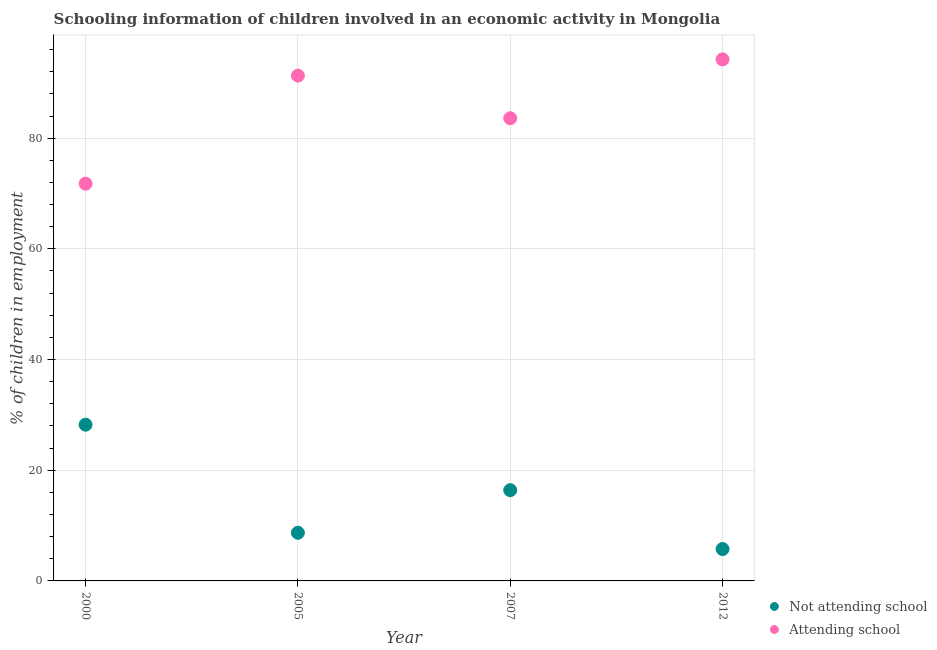How many different coloured dotlines are there?
Your answer should be very brief. 2. What is the percentage of employed children who are attending school in 2005?
Offer a terse response. 91.3. Across all years, what is the maximum percentage of employed children who are attending school?
Ensure brevity in your answer.  94.24. Across all years, what is the minimum percentage of employed children who are not attending school?
Provide a short and direct response. 5.76. What is the total percentage of employed children who are attending school in the graph?
Offer a very short reply. 340.91. What is the difference between the percentage of employed children who are attending school in 2005 and that in 2007?
Your response must be concise. 7.7. What is the difference between the percentage of employed children who are not attending school in 2007 and the percentage of employed children who are attending school in 2005?
Provide a short and direct response. -74.9. What is the average percentage of employed children who are attending school per year?
Provide a short and direct response. 85.23. In the year 2000, what is the difference between the percentage of employed children who are not attending school and percentage of employed children who are attending school?
Your response must be concise. -43.55. In how many years, is the percentage of employed children who are not attending school greater than 52 %?
Make the answer very short. 0. What is the ratio of the percentage of employed children who are not attending school in 2000 to that in 2007?
Offer a terse response. 1.72. Is the percentage of employed children who are attending school in 2000 less than that in 2007?
Keep it short and to the point. Yes. Is the difference between the percentage of employed children who are attending school in 2005 and 2007 greater than the difference between the percentage of employed children who are not attending school in 2005 and 2007?
Your answer should be compact. Yes. What is the difference between the highest and the second highest percentage of employed children who are not attending school?
Provide a short and direct response. 11.83. What is the difference between the highest and the lowest percentage of employed children who are attending school?
Make the answer very short. 22.47. In how many years, is the percentage of employed children who are not attending school greater than the average percentage of employed children who are not attending school taken over all years?
Your answer should be compact. 2. Is the sum of the percentage of employed children who are not attending school in 2000 and 2007 greater than the maximum percentage of employed children who are attending school across all years?
Provide a succinct answer. No. Does the percentage of employed children who are attending school monotonically increase over the years?
Give a very brief answer. No. Is the percentage of employed children who are not attending school strictly greater than the percentage of employed children who are attending school over the years?
Your answer should be compact. No. What is the difference between two consecutive major ticks on the Y-axis?
Make the answer very short. 20. Are the values on the major ticks of Y-axis written in scientific E-notation?
Give a very brief answer. No. Where does the legend appear in the graph?
Make the answer very short. Bottom right. What is the title of the graph?
Your response must be concise. Schooling information of children involved in an economic activity in Mongolia. Does "Urban agglomerations" appear as one of the legend labels in the graph?
Ensure brevity in your answer.  No. What is the label or title of the X-axis?
Your answer should be compact. Year. What is the label or title of the Y-axis?
Offer a terse response. % of children in employment. What is the % of children in employment of Not attending school in 2000?
Offer a very short reply. 28.23. What is the % of children in employment in Attending school in 2000?
Your answer should be very brief. 71.77. What is the % of children in employment of Attending school in 2005?
Ensure brevity in your answer.  91.3. What is the % of children in employment of Attending school in 2007?
Ensure brevity in your answer.  83.6. What is the % of children in employment in Not attending school in 2012?
Your response must be concise. 5.76. What is the % of children in employment of Attending school in 2012?
Offer a very short reply. 94.24. Across all years, what is the maximum % of children in employment of Not attending school?
Ensure brevity in your answer.  28.23. Across all years, what is the maximum % of children in employment in Attending school?
Make the answer very short. 94.24. Across all years, what is the minimum % of children in employment in Not attending school?
Offer a very short reply. 5.76. Across all years, what is the minimum % of children in employment of Attending school?
Your response must be concise. 71.77. What is the total % of children in employment in Not attending school in the graph?
Ensure brevity in your answer.  59.09. What is the total % of children in employment of Attending school in the graph?
Provide a succinct answer. 340.91. What is the difference between the % of children in employment of Not attending school in 2000 and that in 2005?
Offer a terse response. 19.53. What is the difference between the % of children in employment in Attending school in 2000 and that in 2005?
Your answer should be compact. -19.53. What is the difference between the % of children in employment of Not attending school in 2000 and that in 2007?
Provide a succinct answer. 11.83. What is the difference between the % of children in employment in Attending school in 2000 and that in 2007?
Keep it short and to the point. -11.83. What is the difference between the % of children in employment of Not attending school in 2000 and that in 2012?
Provide a succinct answer. 22.47. What is the difference between the % of children in employment in Attending school in 2000 and that in 2012?
Keep it short and to the point. -22.47. What is the difference between the % of children in employment in Not attending school in 2005 and that in 2012?
Make the answer very short. 2.94. What is the difference between the % of children in employment of Attending school in 2005 and that in 2012?
Make the answer very short. -2.94. What is the difference between the % of children in employment in Not attending school in 2007 and that in 2012?
Your answer should be compact. 10.64. What is the difference between the % of children in employment in Attending school in 2007 and that in 2012?
Your answer should be very brief. -10.64. What is the difference between the % of children in employment of Not attending school in 2000 and the % of children in employment of Attending school in 2005?
Your response must be concise. -63.07. What is the difference between the % of children in employment of Not attending school in 2000 and the % of children in employment of Attending school in 2007?
Your answer should be compact. -55.37. What is the difference between the % of children in employment of Not attending school in 2000 and the % of children in employment of Attending school in 2012?
Offer a very short reply. -66.01. What is the difference between the % of children in employment in Not attending school in 2005 and the % of children in employment in Attending school in 2007?
Keep it short and to the point. -74.9. What is the difference between the % of children in employment in Not attending school in 2005 and the % of children in employment in Attending school in 2012?
Offer a very short reply. -85.54. What is the difference between the % of children in employment in Not attending school in 2007 and the % of children in employment in Attending school in 2012?
Give a very brief answer. -77.84. What is the average % of children in employment of Not attending school per year?
Your response must be concise. 14.77. What is the average % of children in employment of Attending school per year?
Provide a succinct answer. 85.23. In the year 2000, what is the difference between the % of children in employment of Not attending school and % of children in employment of Attending school?
Provide a short and direct response. -43.55. In the year 2005, what is the difference between the % of children in employment of Not attending school and % of children in employment of Attending school?
Offer a very short reply. -82.6. In the year 2007, what is the difference between the % of children in employment in Not attending school and % of children in employment in Attending school?
Make the answer very short. -67.2. In the year 2012, what is the difference between the % of children in employment of Not attending school and % of children in employment of Attending school?
Keep it short and to the point. -88.48. What is the ratio of the % of children in employment in Not attending school in 2000 to that in 2005?
Offer a terse response. 3.24. What is the ratio of the % of children in employment in Attending school in 2000 to that in 2005?
Give a very brief answer. 0.79. What is the ratio of the % of children in employment in Not attending school in 2000 to that in 2007?
Make the answer very short. 1.72. What is the ratio of the % of children in employment of Attending school in 2000 to that in 2007?
Make the answer very short. 0.86. What is the ratio of the % of children in employment in Not attending school in 2000 to that in 2012?
Keep it short and to the point. 4.9. What is the ratio of the % of children in employment in Attending school in 2000 to that in 2012?
Provide a succinct answer. 0.76. What is the ratio of the % of children in employment in Not attending school in 2005 to that in 2007?
Your answer should be very brief. 0.53. What is the ratio of the % of children in employment of Attending school in 2005 to that in 2007?
Provide a short and direct response. 1.09. What is the ratio of the % of children in employment in Not attending school in 2005 to that in 2012?
Offer a terse response. 1.51. What is the ratio of the % of children in employment in Attending school in 2005 to that in 2012?
Offer a terse response. 0.97. What is the ratio of the % of children in employment of Not attending school in 2007 to that in 2012?
Offer a very short reply. 2.85. What is the ratio of the % of children in employment in Attending school in 2007 to that in 2012?
Provide a succinct answer. 0.89. What is the difference between the highest and the second highest % of children in employment of Not attending school?
Keep it short and to the point. 11.83. What is the difference between the highest and the second highest % of children in employment of Attending school?
Your answer should be compact. 2.94. What is the difference between the highest and the lowest % of children in employment of Not attending school?
Offer a terse response. 22.47. What is the difference between the highest and the lowest % of children in employment in Attending school?
Keep it short and to the point. 22.47. 